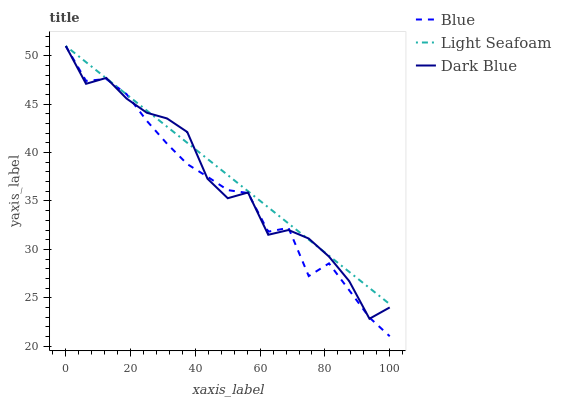Does Blue have the minimum area under the curve?
Answer yes or no. Yes. Does Light Seafoam have the maximum area under the curve?
Answer yes or no. Yes. Does Dark Blue have the minimum area under the curve?
Answer yes or no. No. Does Dark Blue have the maximum area under the curve?
Answer yes or no. No. Is Light Seafoam the smoothest?
Answer yes or no. Yes. Is Dark Blue the roughest?
Answer yes or no. Yes. Is Dark Blue the smoothest?
Answer yes or no. No. Is Light Seafoam the roughest?
Answer yes or no. No. Does Blue have the lowest value?
Answer yes or no. Yes. Does Dark Blue have the lowest value?
Answer yes or no. No. Does Light Seafoam have the highest value?
Answer yes or no. Yes. Does Blue intersect Light Seafoam?
Answer yes or no. Yes. Is Blue less than Light Seafoam?
Answer yes or no. No. Is Blue greater than Light Seafoam?
Answer yes or no. No. 